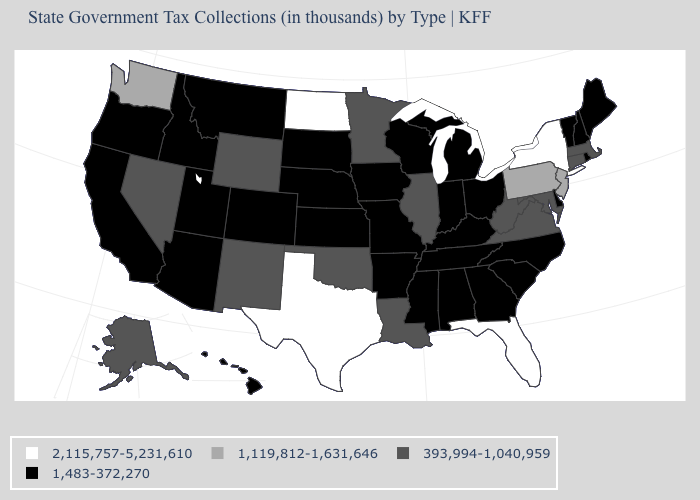What is the value of North Dakota?
Give a very brief answer. 2,115,757-5,231,610. Does the first symbol in the legend represent the smallest category?
Give a very brief answer. No. What is the value of Virginia?
Write a very short answer. 393,994-1,040,959. Is the legend a continuous bar?
Quick response, please. No. How many symbols are there in the legend?
Be succinct. 4. Among the states that border Florida , which have the highest value?
Short answer required. Alabama, Georgia. What is the value of Louisiana?
Be succinct. 393,994-1,040,959. Name the states that have a value in the range 1,119,812-1,631,646?
Concise answer only. New Jersey, Pennsylvania, Washington. What is the value of Wyoming?
Keep it brief. 393,994-1,040,959. What is the lowest value in the MidWest?
Be succinct. 1,483-372,270. Does Texas have the lowest value in the South?
Be succinct. No. Which states have the lowest value in the USA?
Concise answer only. Alabama, Arizona, Arkansas, California, Colorado, Delaware, Georgia, Hawaii, Idaho, Indiana, Iowa, Kansas, Kentucky, Maine, Michigan, Mississippi, Missouri, Montana, Nebraska, New Hampshire, North Carolina, Ohio, Oregon, Rhode Island, South Carolina, South Dakota, Tennessee, Utah, Vermont, Wisconsin. Name the states that have a value in the range 393,994-1,040,959?
Concise answer only. Alaska, Connecticut, Illinois, Louisiana, Maryland, Massachusetts, Minnesota, Nevada, New Mexico, Oklahoma, Virginia, West Virginia, Wyoming. Does Washington have the highest value in the West?
Write a very short answer. Yes. Which states hav the highest value in the South?
Write a very short answer. Florida, Texas. 